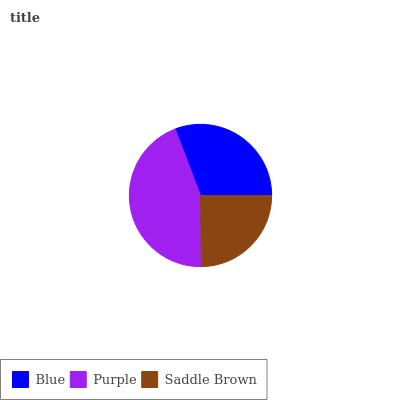Is Saddle Brown the minimum?
Answer yes or no. Yes. Is Purple the maximum?
Answer yes or no. Yes. Is Purple the minimum?
Answer yes or no. No. Is Saddle Brown the maximum?
Answer yes or no. No. Is Purple greater than Saddle Brown?
Answer yes or no. Yes. Is Saddle Brown less than Purple?
Answer yes or no. Yes. Is Saddle Brown greater than Purple?
Answer yes or no. No. Is Purple less than Saddle Brown?
Answer yes or no. No. Is Blue the high median?
Answer yes or no. Yes. Is Blue the low median?
Answer yes or no. Yes. Is Purple the high median?
Answer yes or no. No. Is Purple the low median?
Answer yes or no. No. 